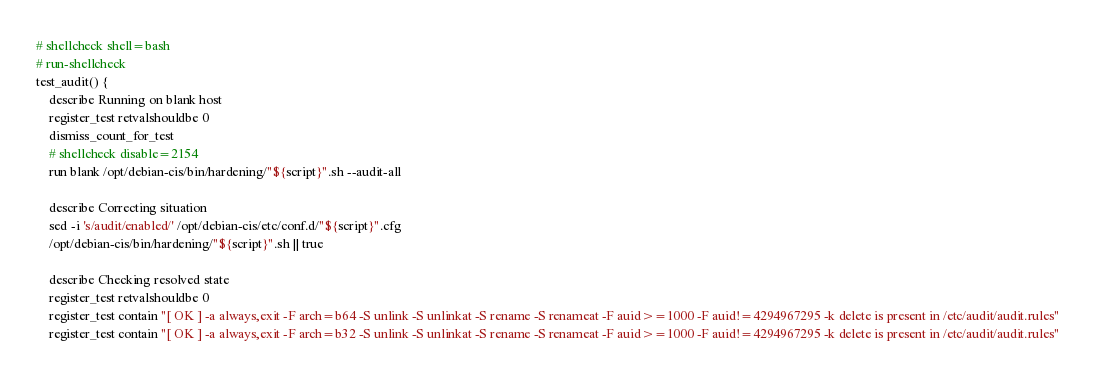Convert code to text. <code><loc_0><loc_0><loc_500><loc_500><_Bash_># shellcheck shell=bash
# run-shellcheck
test_audit() {
    describe Running on blank host
    register_test retvalshouldbe 0
    dismiss_count_for_test
    # shellcheck disable=2154
    run blank /opt/debian-cis/bin/hardening/"${script}".sh --audit-all

    describe Correcting situation
    sed -i 's/audit/enabled/' /opt/debian-cis/etc/conf.d/"${script}".cfg
    /opt/debian-cis/bin/hardening/"${script}".sh || true

    describe Checking resolved state
    register_test retvalshouldbe 0
    register_test contain "[ OK ] -a always,exit -F arch=b64 -S unlink -S unlinkat -S rename -S renameat -F auid>=1000 -F auid!=4294967295 -k delete is present in /etc/audit/audit.rules"
    register_test contain "[ OK ] -a always,exit -F arch=b32 -S unlink -S unlinkat -S rename -S renameat -F auid>=1000 -F auid!=4294967295 -k delete is present in /etc/audit/audit.rules"</code> 